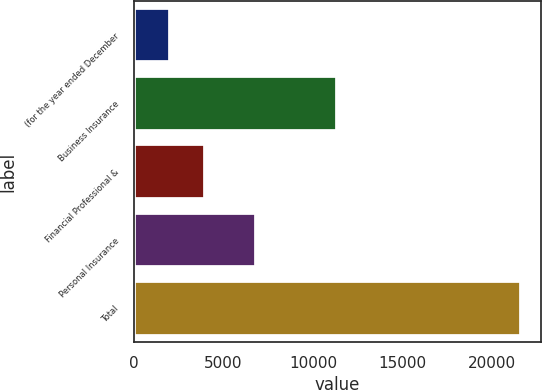<chart> <loc_0><loc_0><loc_500><loc_500><bar_chart><fcel>(for the year ended December<fcel>Business Insurance<fcel>Financial Professional &<fcel>Personal Insurance<fcel>Total<nl><fcel>2007<fcel>11318<fcel>3968.1<fcel>6835<fcel>21618<nl></chart> 